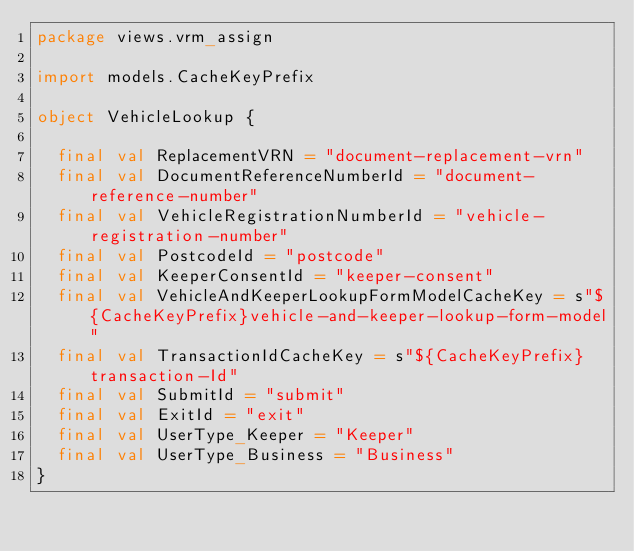<code> <loc_0><loc_0><loc_500><loc_500><_Scala_>package views.vrm_assign

import models.CacheKeyPrefix

object VehicleLookup {

  final val ReplacementVRN = "document-replacement-vrn"
  final val DocumentReferenceNumberId = "document-reference-number"
  final val VehicleRegistrationNumberId = "vehicle-registration-number"
  final val PostcodeId = "postcode"
  final val KeeperConsentId = "keeper-consent"
  final val VehicleAndKeeperLookupFormModelCacheKey = s"${CacheKeyPrefix}vehicle-and-keeper-lookup-form-model"
  final val TransactionIdCacheKey = s"${CacheKeyPrefix}transaction-Id"
  final val SubmitId = "submit"
  final val ExitId = "exit"
  final val UserType_Keeper = "Keeper"
  final val UserType_Business = "Business"
}</code> 